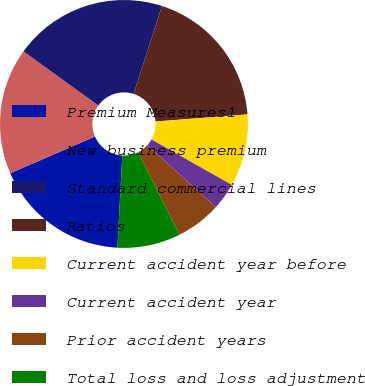<chart> <loc_0><loc_0><loc_500><loc_500><pie_chart><fcel>Premium Measures1<fcel>New business premium<fcel>Standard commercial lines<fcel>Ratios<fcel>Current accident year before<fcel>Current accident year<fcel>Prior accident years<fcel>Total loss and loss adjustment<nl><fcel>17.65%<fcel>16.47%<fcel>20.0%<fcel>18.82%<fcel>9.41%<fcel>3.53%<fcel>5.88%<fcel>8.24%<nl></chart> 